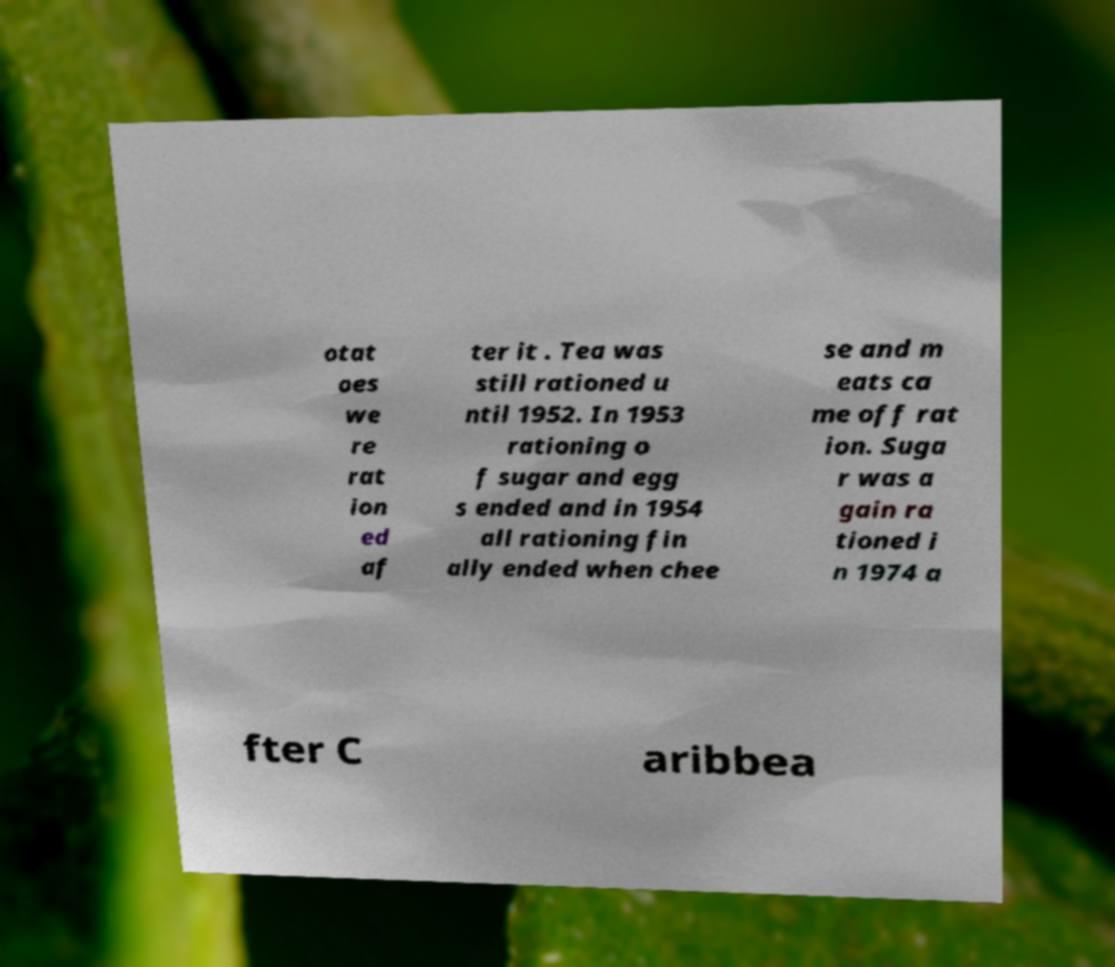Could you extract and type out the text from this image? otat oes we re rat ion ed af ter it . Tea was still rationed u ntil 1952. In 1953 rationing o f sugar and egg s ended and in 1954 all rationing fin ally ended when chee se and m eats ca me off rat ion. Suga r was a gain ra tioned i n 1974 a fter C aribbea 